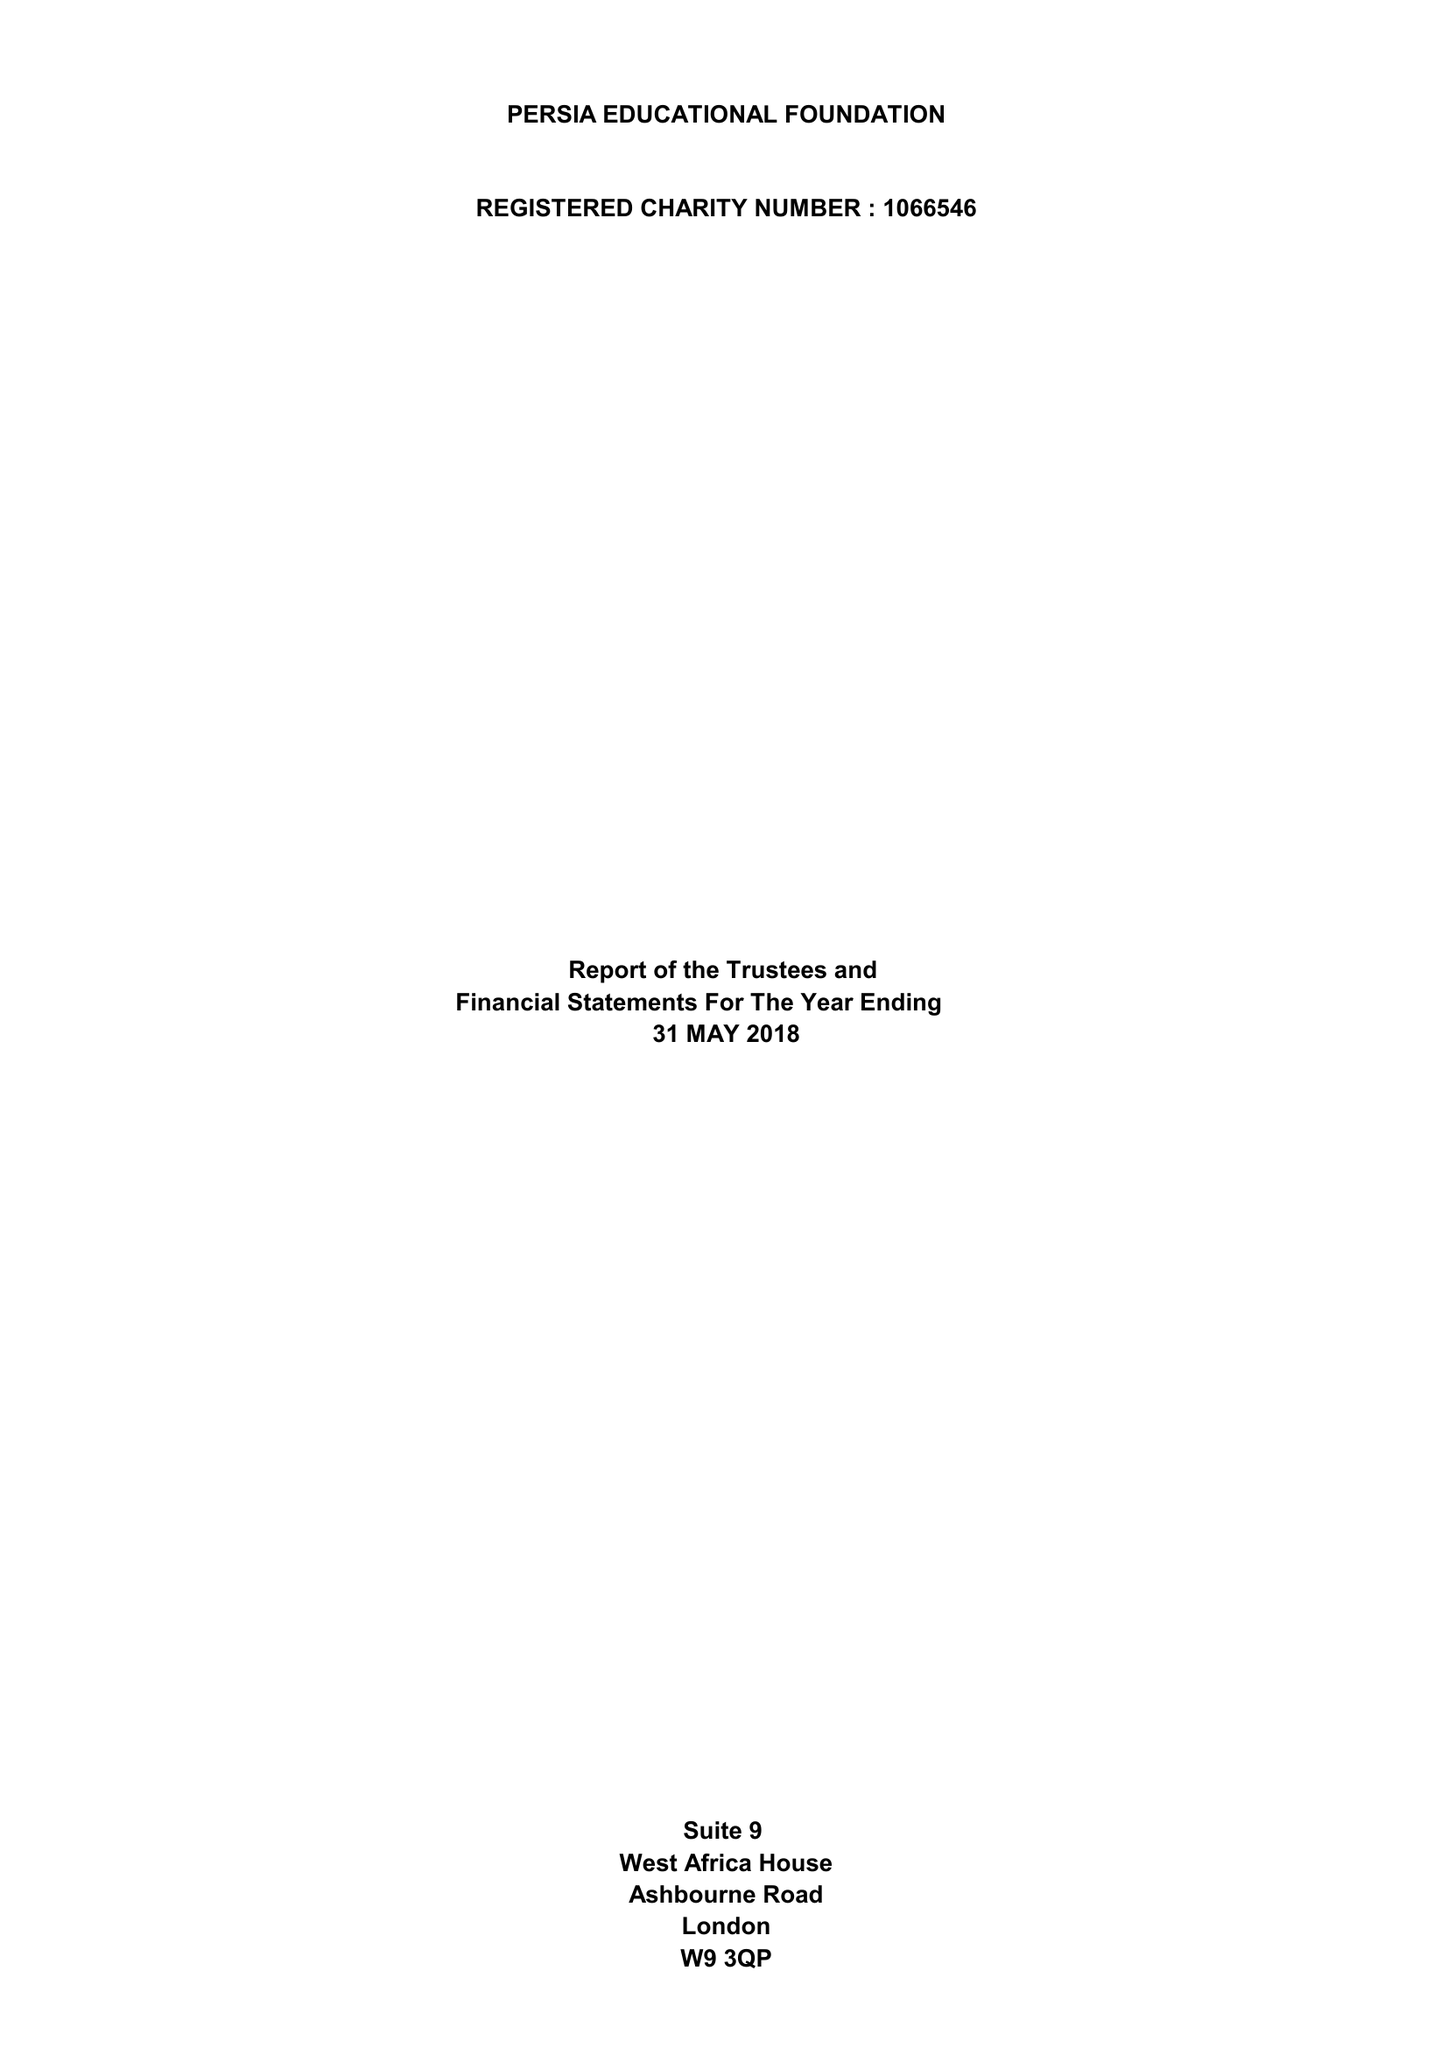What is the value for the report_date?
Answer the question using a single word or phrase. 2018-05-31 